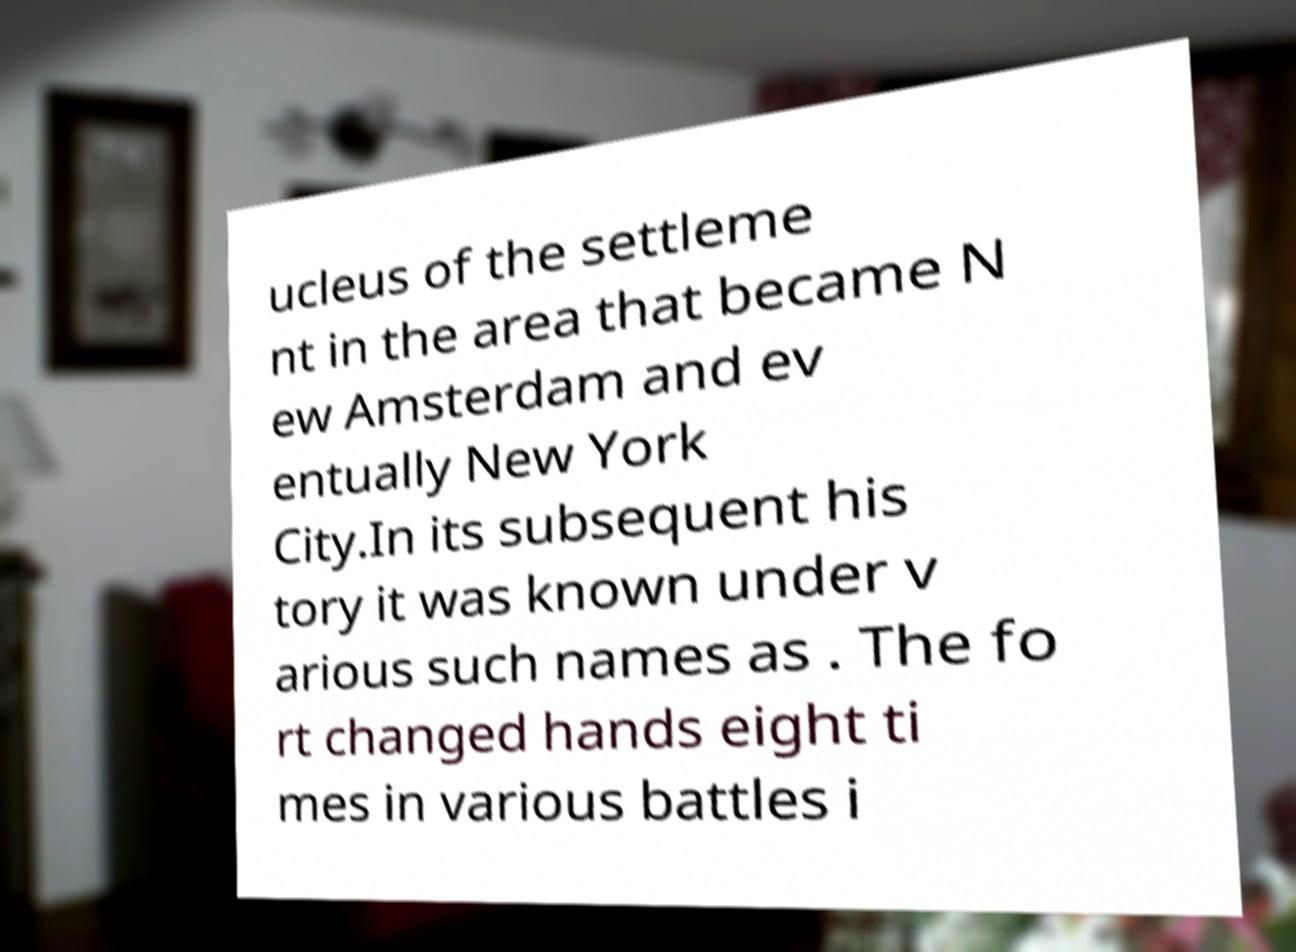Could you assist in decoding the text presented in this image and type it out clearly? ucleus of the settleme nt in the area that became N ew Amsterdam and ev entually New York City.In its subsequent his tory it was known under v arious such names as . The fo rt changed hands eight ti mes in various battles i 